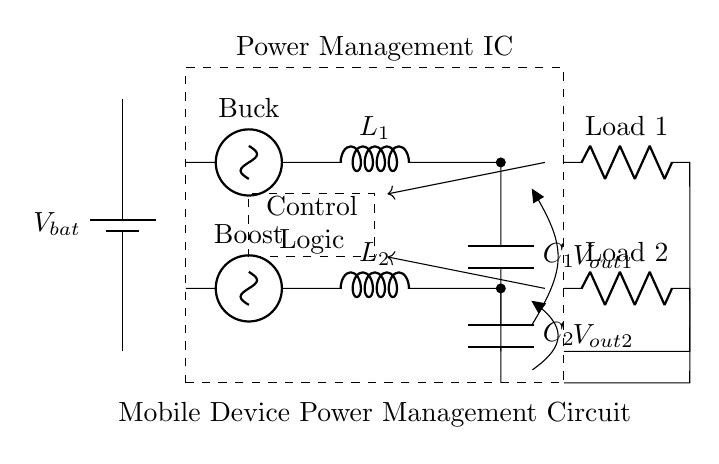What is the battery voltage in the circuit? The circuit shows a battery labeled with V bat. In typical power management circuits for mobile devices, the battery voltage is usually a nominal voltage, which could be either 3.7V or 5V. However, without specific values on the diagram, we cannot determine the exact voltage.
Answer: V bat What do the inductors represent in this circuit? The circuit includes two inductors labeled L1 and L2, which indicate that they are part of a buck converter and a boost converter respectively. Inductors are used to store energy and control current flow in the circuit.
Answer: Inductors Which component is responsible for voltage regulation? The control logic, represented by the dashed rectangle, manages the operation of the buck and boost converters to regulate the output voltage levels based on the load requirements. It determines how the power management IC adjusts the output to maximize efficiency.
Answer: Control Logic How many output capacitors are present in the circuit? The circuit contains two output capacitors labeled C1 and C2, connected to the outputs of the buck and boost converters. These capacitors are essential for smoothing the voltage output and ensuring stable operation of the load circuits.
Answer: Two What is the main purpose of the power management IC in this circuit? The power management IC is designed to optimize battery life in mobile devices by effectively managing power distribution between the battery, buck converter, boost converter, and the load. It does this by ensuring that the voltage and current supplied meet the demands of the devices while minimizing energy loss.
Answer: Optimize battery life How do feedback lines function in this circuit? Feedback lines in the circuit are used to return information about the output voltage levels (V out1 and V out2) back to the control logic. This allows the control logic to adjust the operation of the converters based on the actual output voltage compared to the desired output, hence ensuring proper voltage regulation.
Answer: Adjust output voltage 